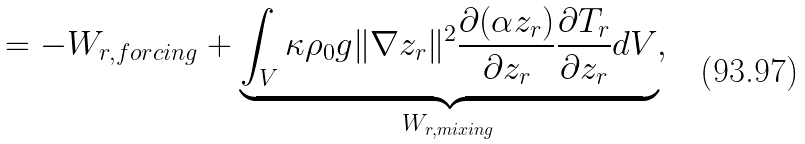<formula> <loc_0><loc_0><loc_500><loc_500>= - W _ { r , f o r c i n g } + \underbrace { \int _ { V } \kappa \rho _ { 0 } g \| \nabla z _ { r } \| ^ { 2 } \frac { \partial ( \alpha z _ { r } ) } { \partial z _ { r } } \frac { \partial T _ { r } } { \partial z _ { r } } d V } _ { W _ { r , m i x i n g } } ,</formula> 